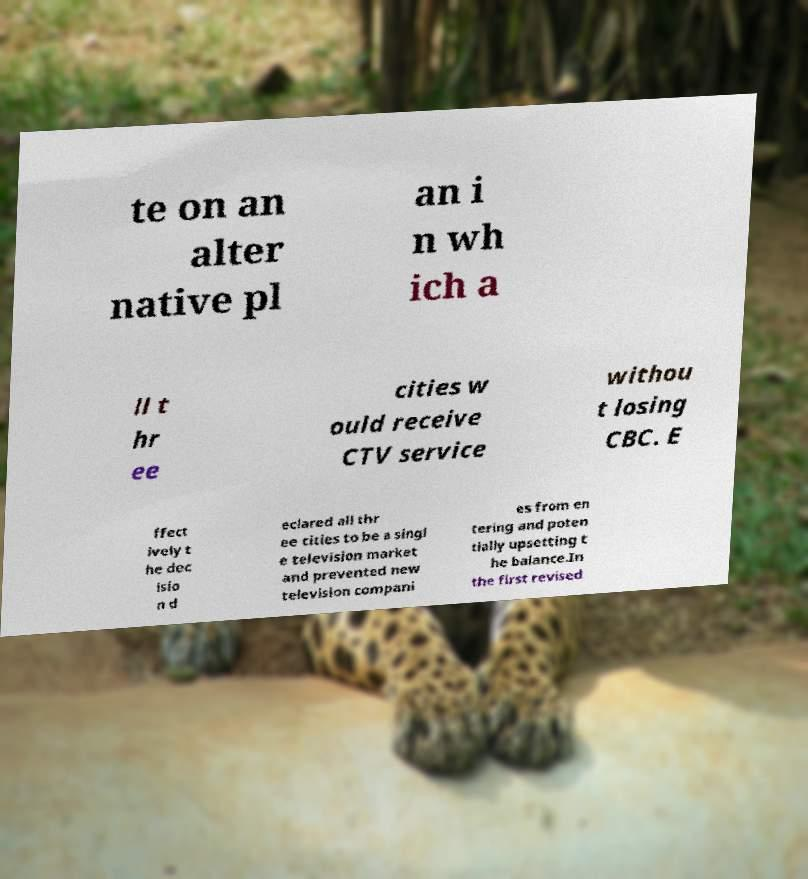What messages or text are displayed in this image? I need them in a readable, typed format. te on an alter native pl an i n wh ich a ll t hr ee cities w ould receive CTV service withou t losing CBC. E ffect ively t he dec isio n d eclared all thr ee cities to be a singl e television market and prevented new television compani es from en tering and poten tially upsetting t he balance.In the first revised 